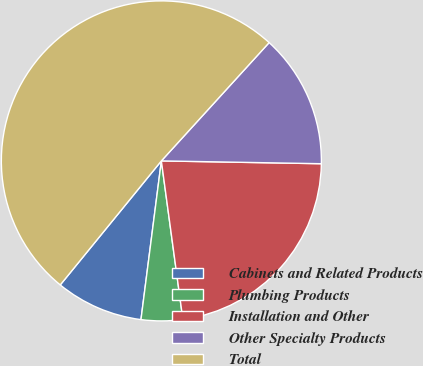<chart> <loc_0><loc_0><loc_500><loc_500><pie_chart><fcel>Cabinets and Related Products<fcel>Plumbing Products<fcel>Installation and Other<fcel>Other Specialty Products<fcel>Total<nl><fcel>8.85%<fcel>4.18%<fcel>22.57%<fcel>13.52%<fcel>50.87%<nl></chart> 